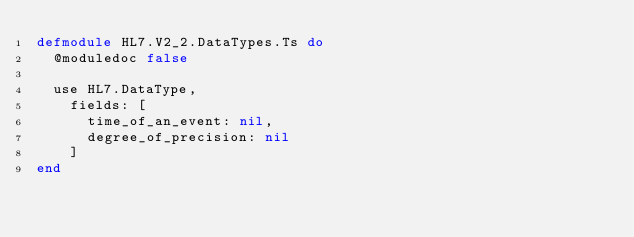<code> <loc_0><loc_0><loc_500><loc_500><_Elixir_>defmodule HL7.V2_2.DataTypes.Ts do
  @moduledoc false

  use HL7.DataType,
    fields: [
      time_of_an_event: nil,
      degree_of_precision: nil
    ]
end
</code> 